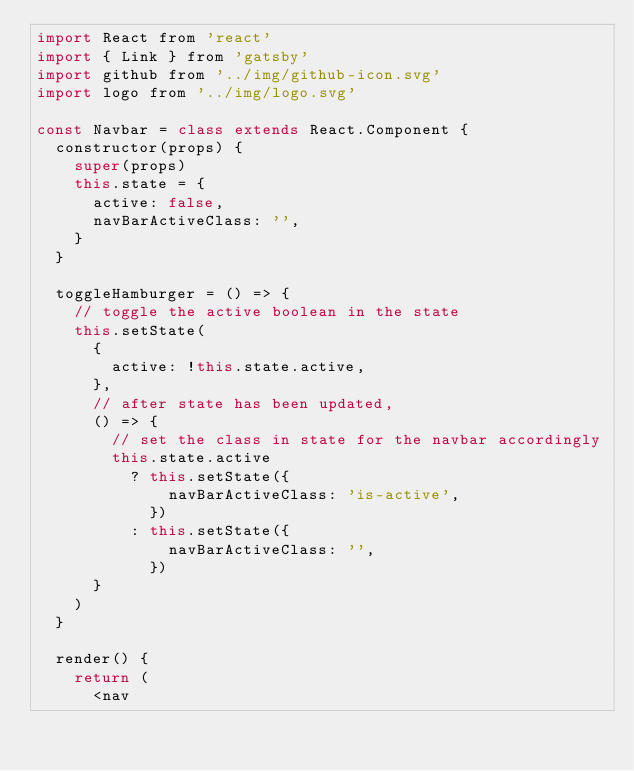Convert code to text. <code><loc_0><loc_0><loc_500><loc_500><_JavaScript_>import React from 'react'
import { Link } from 'gatsby'
import github from '../img/github-icon.svg'
import logo from '../img/logo.svg'

const Navbar = class extends React.Component {
  constructor(props) {
    super(props)
    this.state = {
      active: false,
      navBarActiveClass: '',
    }
  }

  toggleHamburger = () => {
    // toggle the active boolean in the state
    this.setState(
      {
        active: !this.state.active,
      },
      // after state has been updated,
      () => {
        // set the class in state for the navbar accordingly
        this.state.active
          ? this.setState({
              navBarActiveClass: 'is-active',
            })
          : this.setState({
              navBarActiveClass: '',
            })
      }
    )
  }

  render() {
    return (
      <nav</code> 